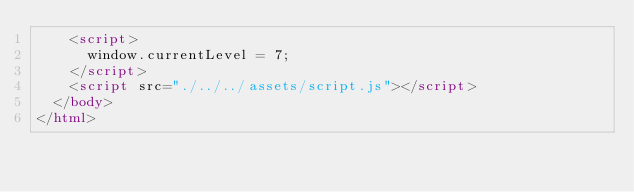<code> <loc_0><loc_0><loc_500><loc_500><_HTML_>    <script>
      window.currentLevel = 7;
    </script>
    <script src="./../../assets/script.js"></script>
  </body>
</html></code> 